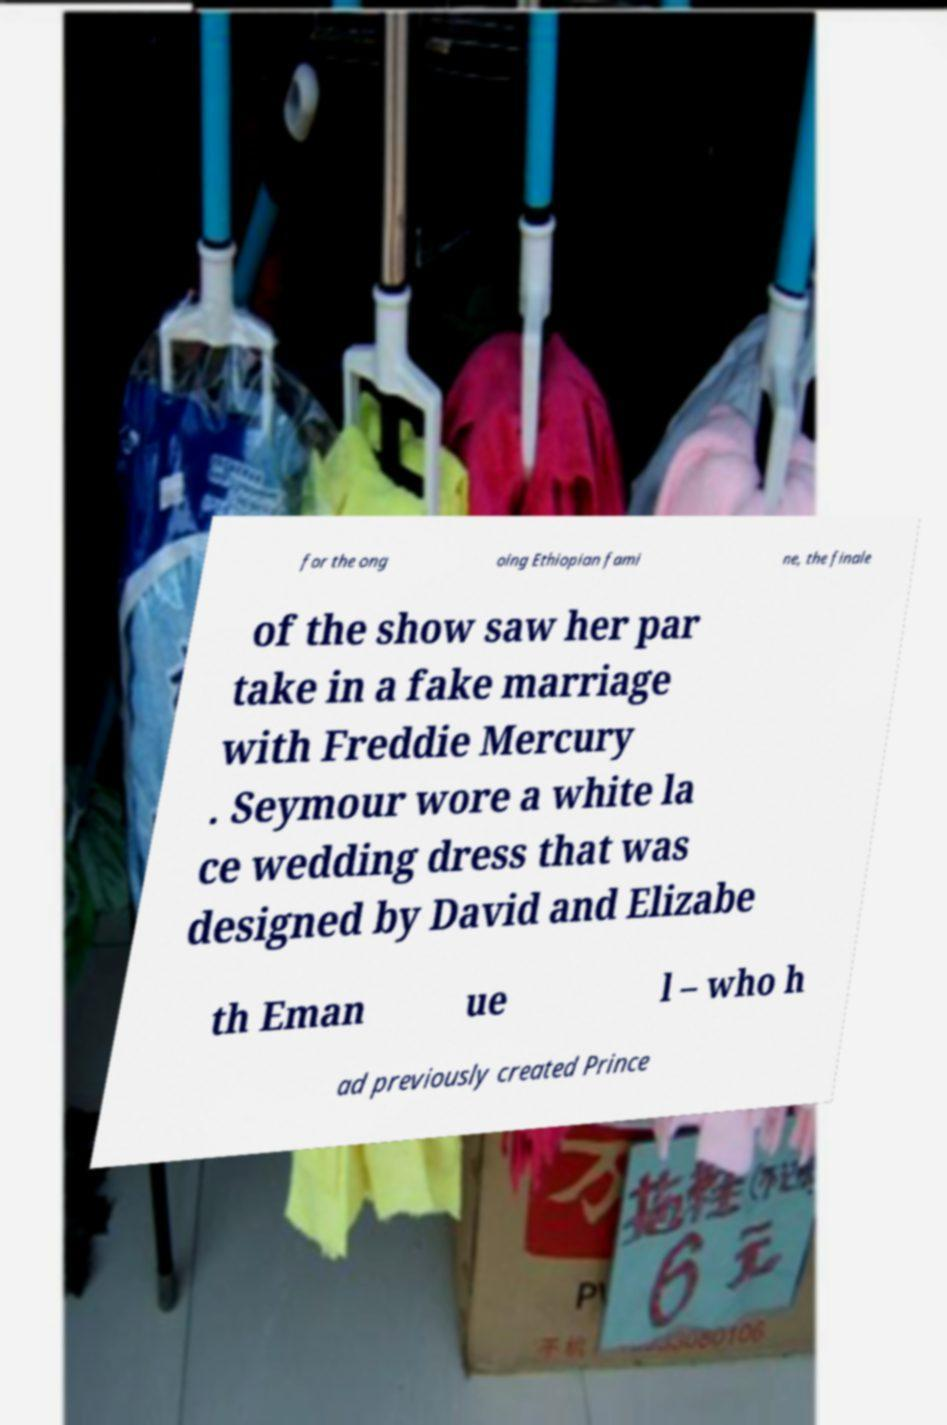Please identify and transcribe the text found in this image. for the ong oing Ethiopian fami ne, the finale of the show saw her par take in a fake marriage with Freddie Mercury . Seymour wore a white la ce wedding dress that was designed by David and Elizabe th Eman ue l – who h ad previously created Prince 